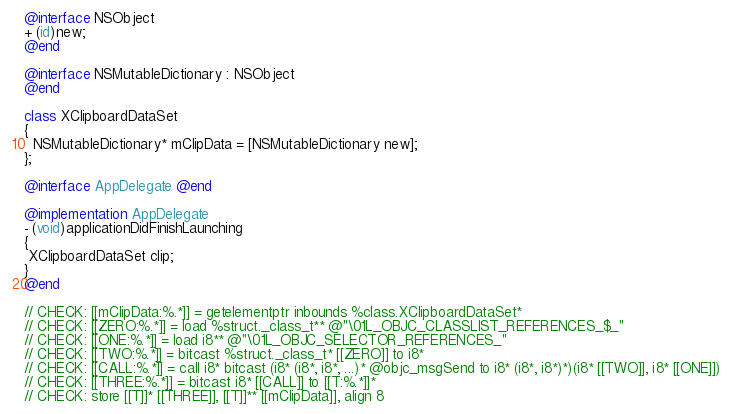Convert code to text. <code><loc_0><loc_0><loc_500><loc_500><_ObjectiveC_>@interface NSObject
+ (id)new;
@end

@interface NSMutableDictionary : NSObject
@end
  
class XClipboardDataSet
{ 
  NSMutableDictionary* mClipData = [NSMutableDictionary new];
};
  
@interface AppDelegate @end

@implementation AppDelegate
- (void)applicationDidFinishLaunching
{ 
 XClipboardDataSet clip; 
}
@end

// CHECK: [[mClipData:%.*]] = getelementptr inbounds %class.XClipboardDataSet* 
// CHECK: [[ZERO:%.*]] = load %struct._class_t** @"\01L_OBJC_CLASSLIST_REFERENCES_$_"
// CHECK: [[ONE:%.*]] = load i8** @"\01L_OBJC_SELECTOR_REFERENCES_"
// CHECK: [[TWO:%.*]] = bitcast %struct._class_t* [[ZERO]] to i8*
// CHECK: [[CALL:%.*]] = call i8* bitcast (i8* (i8*, i8*, ...)* @objc_msgSend to i8* (i8*, i8*)*)(i8* [[TWO]], i8* [[ONE]])
// CHECK: [[THREE:%.*]] = bitcast i8* [[CALL]] to [[T:%.*]]*
// CHECK: store [[T]]* [[THREE]], [[T]]** [[mClipData]], align 8

</code> 